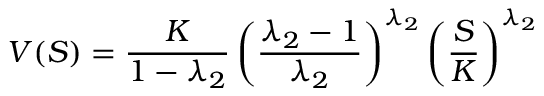<formula> <loc_0><loc_0><loc_500><loc_500>V ( S ) = { \frac { K } { 1 - \lambda _ { 2 } } } \left ( { \frac { \lambda _ { 2 } - 1 } { \lambda _ { 2 } } } \right ) ^ { \lambda _ { 2 } } \left ( { \frac { S } { K } } \right ) ^ { \lambda _ { 2 } }</formula> 